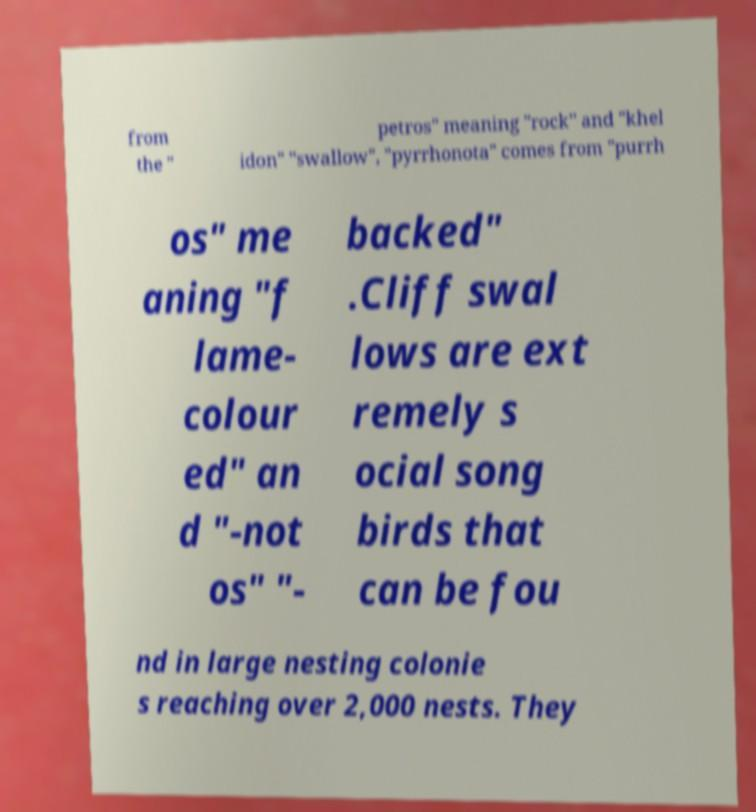Could you assist in decoding the text presented in this image and type it out clearly? from the " petros" meaning "rock" and "khel idon" "swallow", "pyrrhonota" comes from "purrh os" me aning "f lame- colour ed" an d "-not os" "- backed" .Cliff swal lows are ext remely s ocial song birds that can be fou nd in large nesting colonie s reaching over 2,000 nests. They 